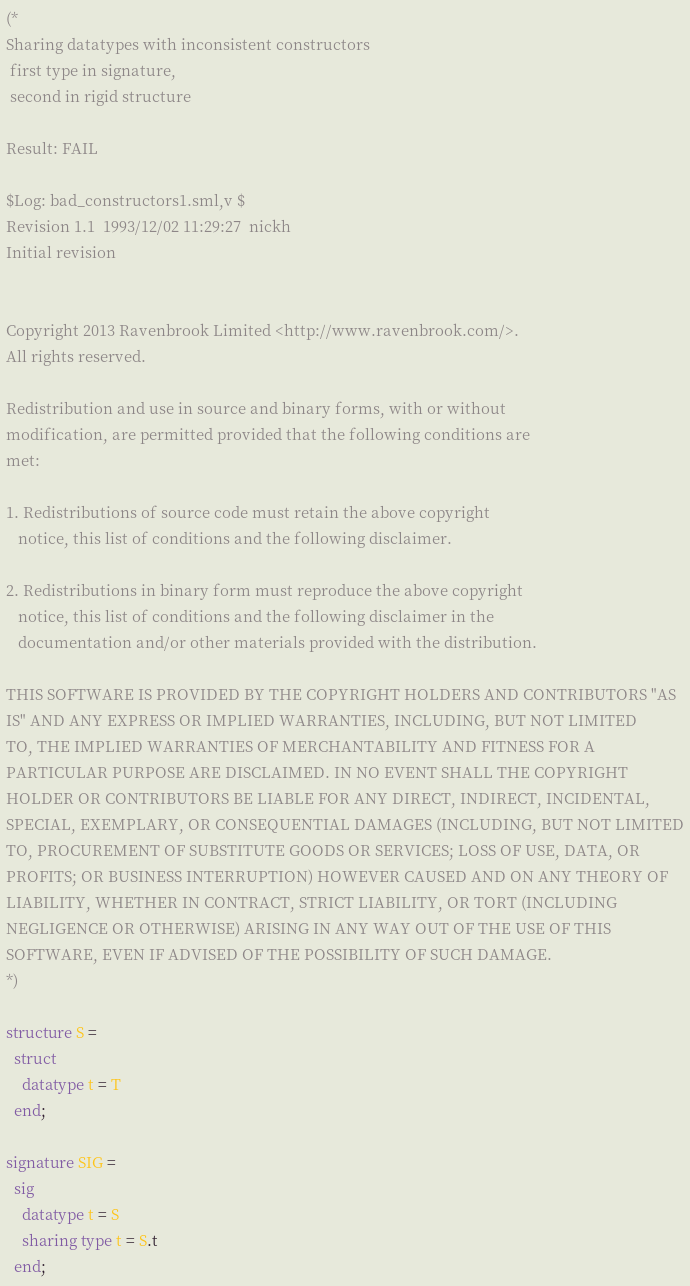Convert code to text. <code><loc_0><loc_0><loc_500><loc_500><_SML_>(*
Sharing datatypes with inconsistent constructors
 first type in signature,
 second in rigid structure

Result: FAIL
 
$Log: bad_constructors1.sml,v $
Revision 1.1  1993/12/02 11:29:27  nickh
Initial revision


Copyright 2013 Ravenbrook Limited <http://www.ravenbrook.com/>.
All rights reserved.

Redistribution and use in source and binary forms, with or without
modification, are permitted provided that the following conditions are
met:

1. Redistributions of source code must retain the above copyright
   notice, this list of conditions and the following disclaimer.

2. Redistributions in binary form must reproduce the above copyright
   notice, this list of conditions and the following disclaimer in the
   documentation and/or other materials provided with the distribution.

THIS SOFTWARE IS PROVIDED BY THE COPYRIGHT HOLDERS AND CONTRIBUTORS "AS
IS" AND ANY EXPRESS OR IMPLIED WARRANTIES, INCLUDING, BUT NOT LIMITED
TO, THE IMPLIED WARRANTIES OF MERCHANTABILITY AND FITNESS FOR A
PARTICULAR PURPOSE ARE DISCLAIMED. IN NO EVENT SHALL THE COPYRIGHT
HOLDER OR CONTRIBUTORS BE LIABLE FOR ANY DIRECT, INDIRECT, INCIDENTAL,
SPECIAL, EXEMPLARY, OR CONSEQUENTIAL DAMAGES (INCLUDING, BUT NOT LIMITED
TO, PROCUREMENT OF SUBSTITUTE GOODS OR SERVICES; LOSS OF USE, DATA, OR
PROFITS; OR BUSINESS INTERRUPTION) HOWEVER CAUSED AND ON ANY THEORY OF
LIABILITY, WHETHER IN CONTRACT, STRICT LIABILITY, OR TORT (INCLUDING
NEGLIGENCE OR OTHERWISE) ARISING IN ANY WAY OUT OF THE USE OF THIS
SOFTWARE, EVEN IF ADVISED OF THE POSSIBILITY OF SUCH DAMAGE.
*)

structure S =
  struct
    datatype t = T
  end;

signature SIG =
  sig
    datatype t = S
    sharing type t = S.t
  end;
</code> 